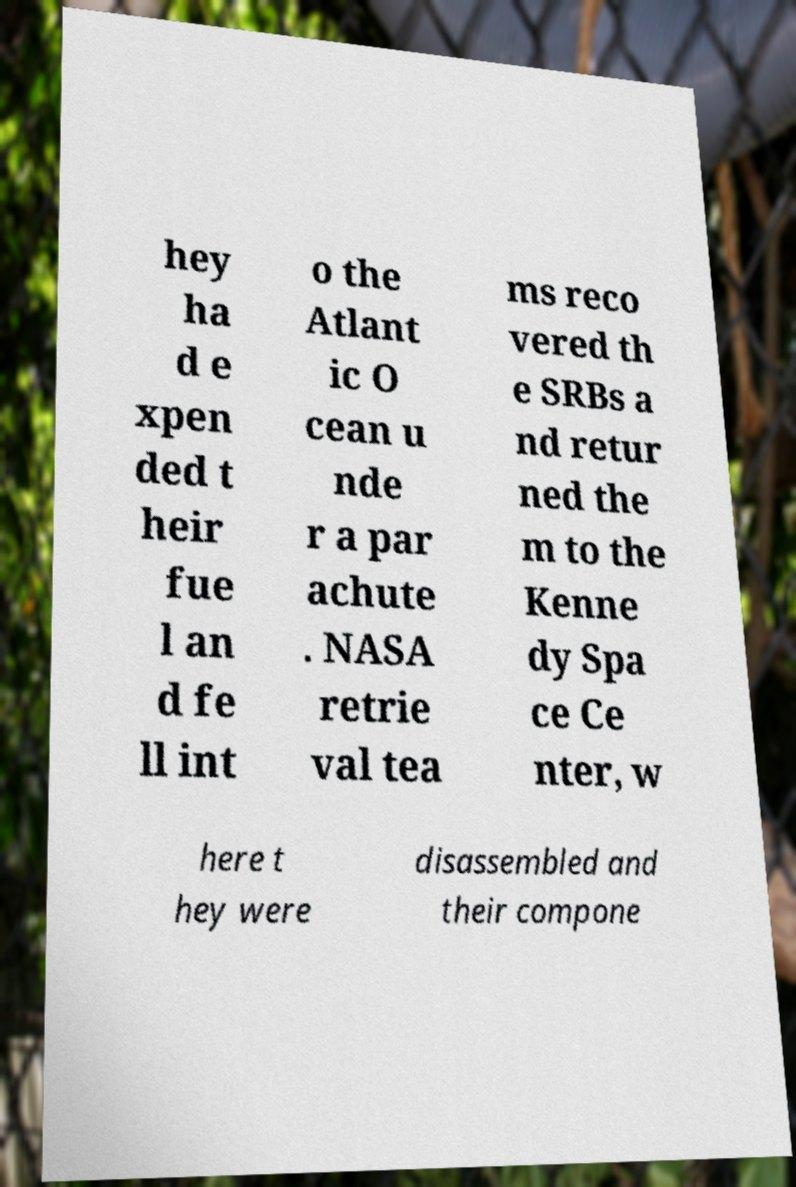Could you assist in decoding the text presented in this image and type it out clearly? hey ha d e xpen ded t heir fue l an d fe ll int o the Atlant ic O cean u nde r a par achute . NASA retrie val tea ms reco vered th e SRBs a nd retur ned the m to the Kenne dy Spa ce Ce nter, w here t hey were disassembled and their compone 